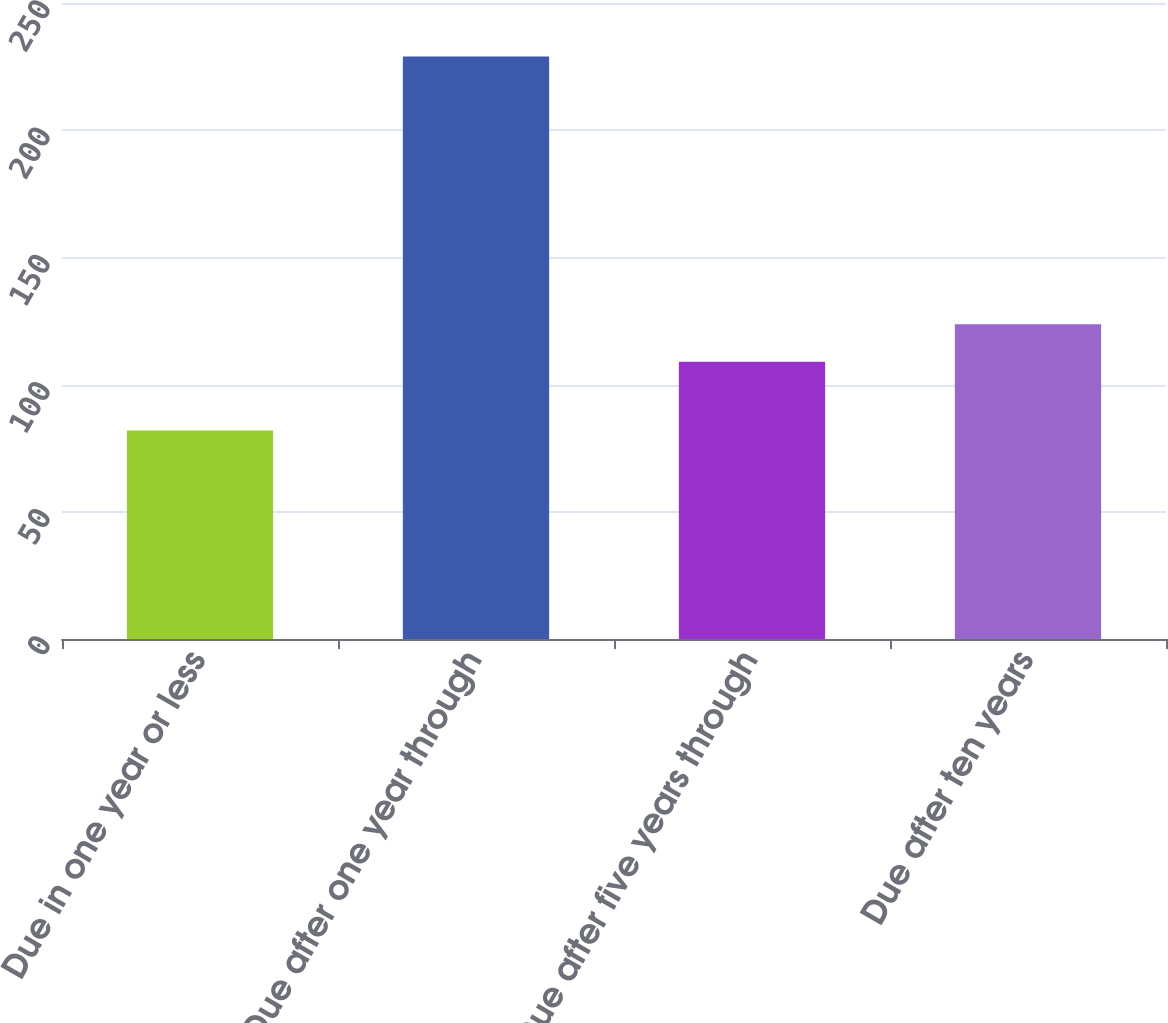Convert chart to OTSL. <chart><loc_0><loc_0><loc_500><loc_500><bar_chart><fcel>Due in one year or less<fcel>Due after one year through<fcel>Due after five years through<fcel>Due after ten years<nl><fcel>82<fcel>229<fcel>109<fcel>123.7<nl></chart> 